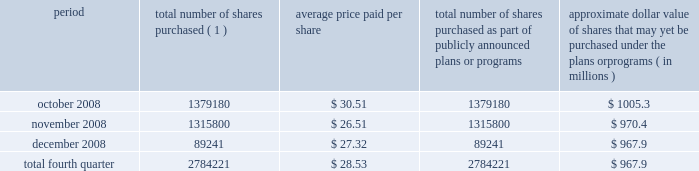Act of 1933 , as amended , and section 1145 of the united states code .
No underwriters were engaged in connection with such issuances .
During the three months ended december 31 , 2008 , we issued an aggregate of 7173456 shares of our common stock upon conversion of $ 147.1 million principal amount of our 3.00% ( 3.00 % ) notes .
Pursuant to the terms of the indenture , holders of the 3.00% ( 3.00 % ) notes receive 48.7805 shares of our common stock for every $ 1000 principal amount of notes converted .
In connection with the conversions , we paid such holders an aggregate of approximately $ 3.7 million , calculated based on the accrued and unpaid interest on the notes and the discounted value of the future interest payments on the notes .
All shares were issued in reliance on the exemption from registration set forth in section 3 ( a ) ( 9 ) of the securities act of 1933 , as amended .
No underwriters were engaged in connection with such issuances .
Issuer purchases of equity securities during the three months ended december 31 , 2008 , we repurchased 2784221 shares of our common stock for an aggregate of $ 79.4 million , including commissions and fees , pursuant to our publicly announced stock repurchase program , as follows : period total number of shares purchased ( 1 ) average price paid per share total number of shares purchased as part of publicly announced plans or programs approximate dollar value of shares that may yet be purchased under the plans or programs ( in millions ) .
( 1 ) repurchases made pursuant to the $ 1.5 billion stock repurchase program approved by our board of directors in february 2008 .
Under this program , our management is authorized to purchase shares from time to time through open market purchases or privately negotiated transactions at prevailing prices as permitted by securities laws and other legal requirements , and subject to market conditions and other factors .
To facilitate repurchases , we make purchases pursuant to a trading plan under rule 10b5-1 of the exchange act , which allows us to repurchase shares during periods when we otherwise might be prevented from doing so under insider trading laws or because of self-imposed trading blackout periods .
This program may be discontinued at any time .
As reflected in the above table , in the fourth quarter of 2008 , we significantly reduced purchases of common stock under our stock repurchase program based on the downturn in the economy and the disruptions in the financial and credit markets .
Subsequent to december 31 , 2008 , we repurchased approximately 28000 shares of our common stock for an aggregate of $ 0.8 million , including commissions and fees , pursuant to this program .
We expect to continue to manage the pacing of the program in the future in response to general market conditions and other relevant factors. .
What is the percentage change in the average price for repurchased shares from october to december 2008? 
Computations: ((27.32 - 30.51) / 30.51)
Answer: -0.10456. 